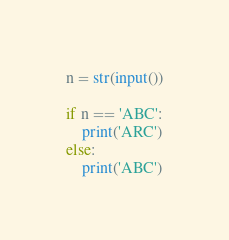<code> <loc_0><loc_0><loc_500><loc_500><_Python_>n = str(input())

if n == 'ABC':
    print('ARC')
else:
    print('ABC')
</code> 